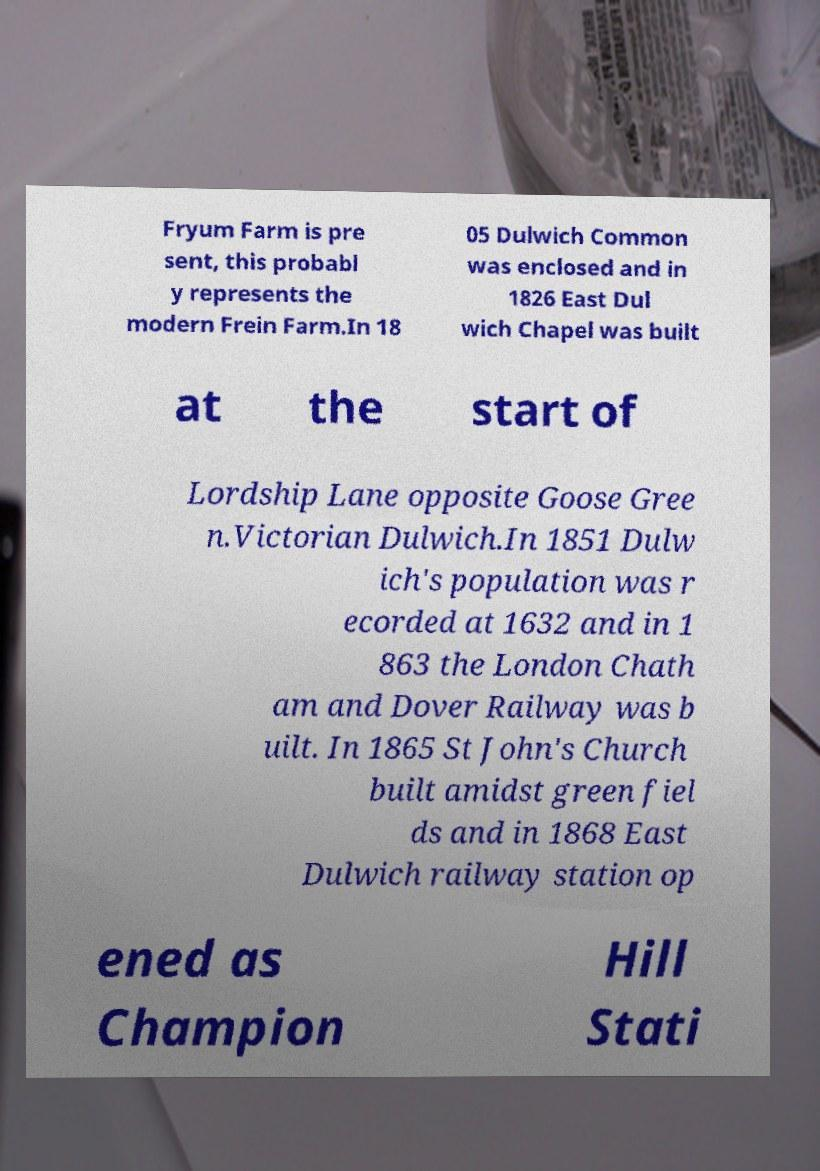Please read and relay the text visible in this image. What does it say? Fryum Farm is pre sent, this probabl y represents the modern Frein Farm.In 18 05 Dulwich Common was enclosed and in 1826 East Dul wich Chapel was built at the start of Lordship Lane opposite Goose Gree n.Victorian Dulwich.In 1851 Dulw ich's population was r ecorded at 1632 and in 1 863 the London Chath am and Dover Railway was b uilt. In 1865 St John's Church built amidst green fiel ds and in 1868 East Dulwich railway station op ened as Champion Hill Stati 